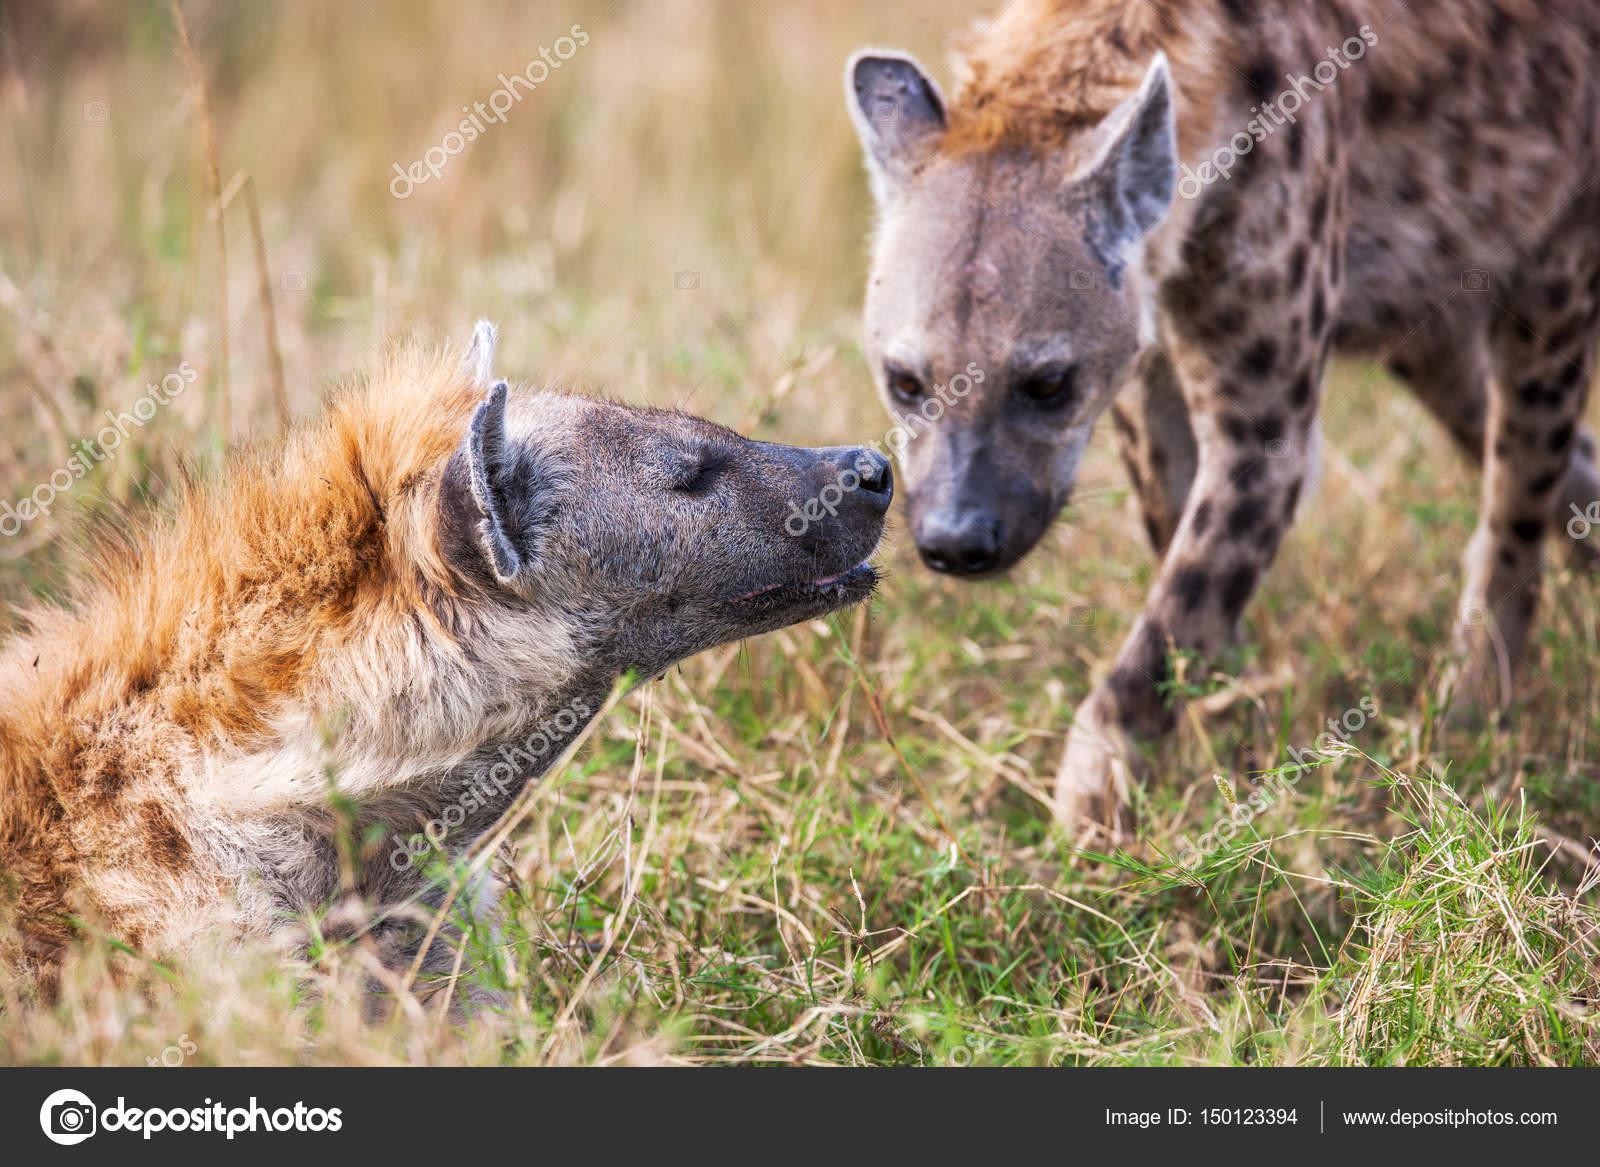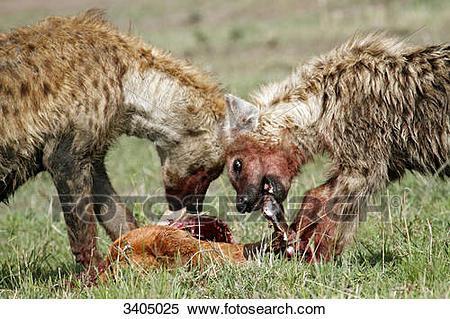The first image is the image on the left, the second image is the image on the right. Given the left and right images, does the statement "An image shows two hyenas posed nose to nose, with no carcass between them." hold true? Answer yes or no. Yes. The first image is the image on the left, the second image is the image on the right. For the images displayed, is the sentence "One animal is lying down and another is standing in at least one of the images." factually correct? Answer yes or no. Yes. 